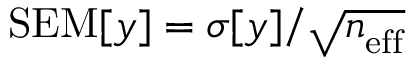Convert formula to latex. <formula><loc_0><loc_0><loc_500><loc_500>S E M [ y ] = \sigma [ y ] / \sqrt { n _ { e f f } }</formula> 